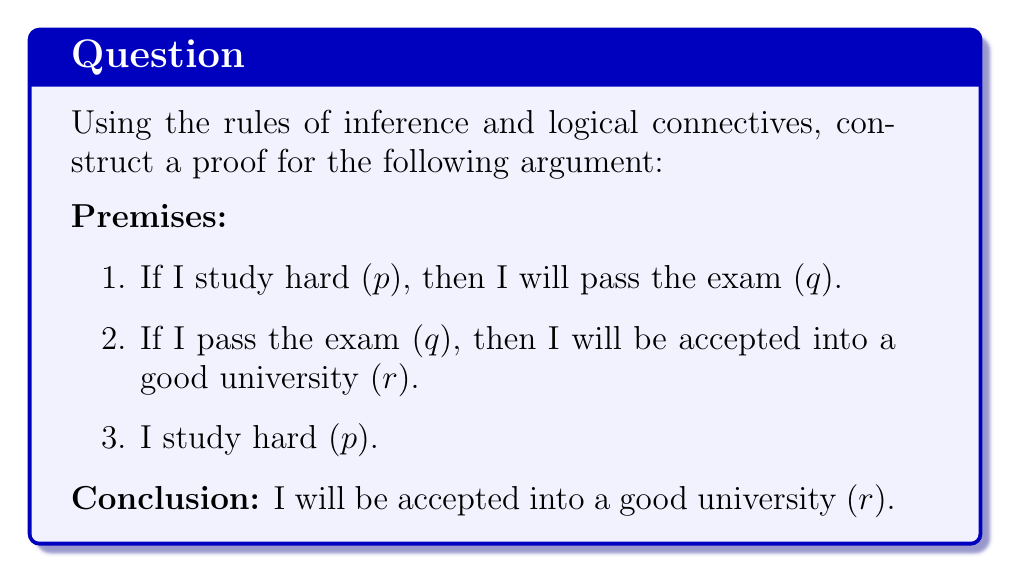Help me with this question. Let's construct a proof using the rules of inference and logical connectives:

1. We start with the given premises:
   a. $p \rightarrow q$ (If I study hard, then I will pass the exam)
   b. $q \rightarrow r$ (If I pass the exam, then I will be accepted into a good university)
   c. $p$ (I study hard)

2. From premises (a) and (c), we can apply the Modus Ponens rule of inference:
   $p \rightarrow q$
   $p$
   ∴ $q$
   
   This gives us: I will pass the exam ($q$).

3. Now we have:
   $q \rightarrow r$ (from premise b)
   $q$ (from step 2)

4. We can apply Modus Ponens again:
   $q \rightarrow r$
   $q$
   ∴ $r$

5. Therefore, we have proved: I will be accepted into a good university ($r$).

This proof uses the following rules of inference and logical connectives:
- Modus Ponens (If $P$, then $Q$; $P$; therefore $Q$)
- Conditional statements ($\rightarrow$)
- Logical conjunction (combining premises)
Answer: The proof is valid. The conclusion "I will be accepted into a good university ($r$)" follows logically from the given premises using the rules of inference (specifically, two applications of Modus Ponens) and logical connectives. 